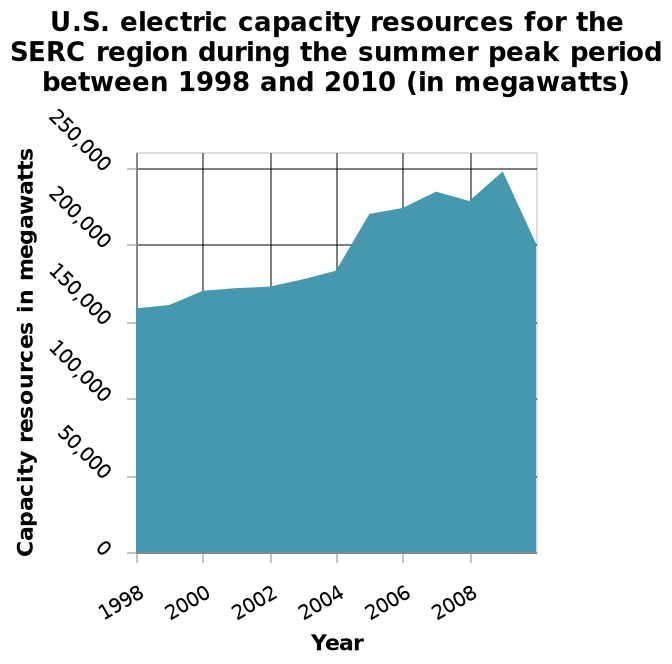<image>
What time period does the area chart cover? The area chart covers the years between 1998 and 2010. What is the focus of the area chart in the SERC region?  The area chart focuses on the U.S. electric capacity resources in the SERC region during the summer peak period between 1998 and 2010. 